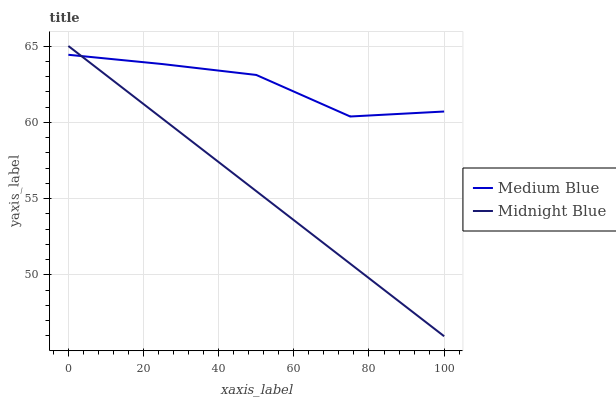Does Midnight Blue have the maximum area under the curve?
Answer yes or no. No. Is Midnight Blue the roughest?
Answer yes or no. No. 